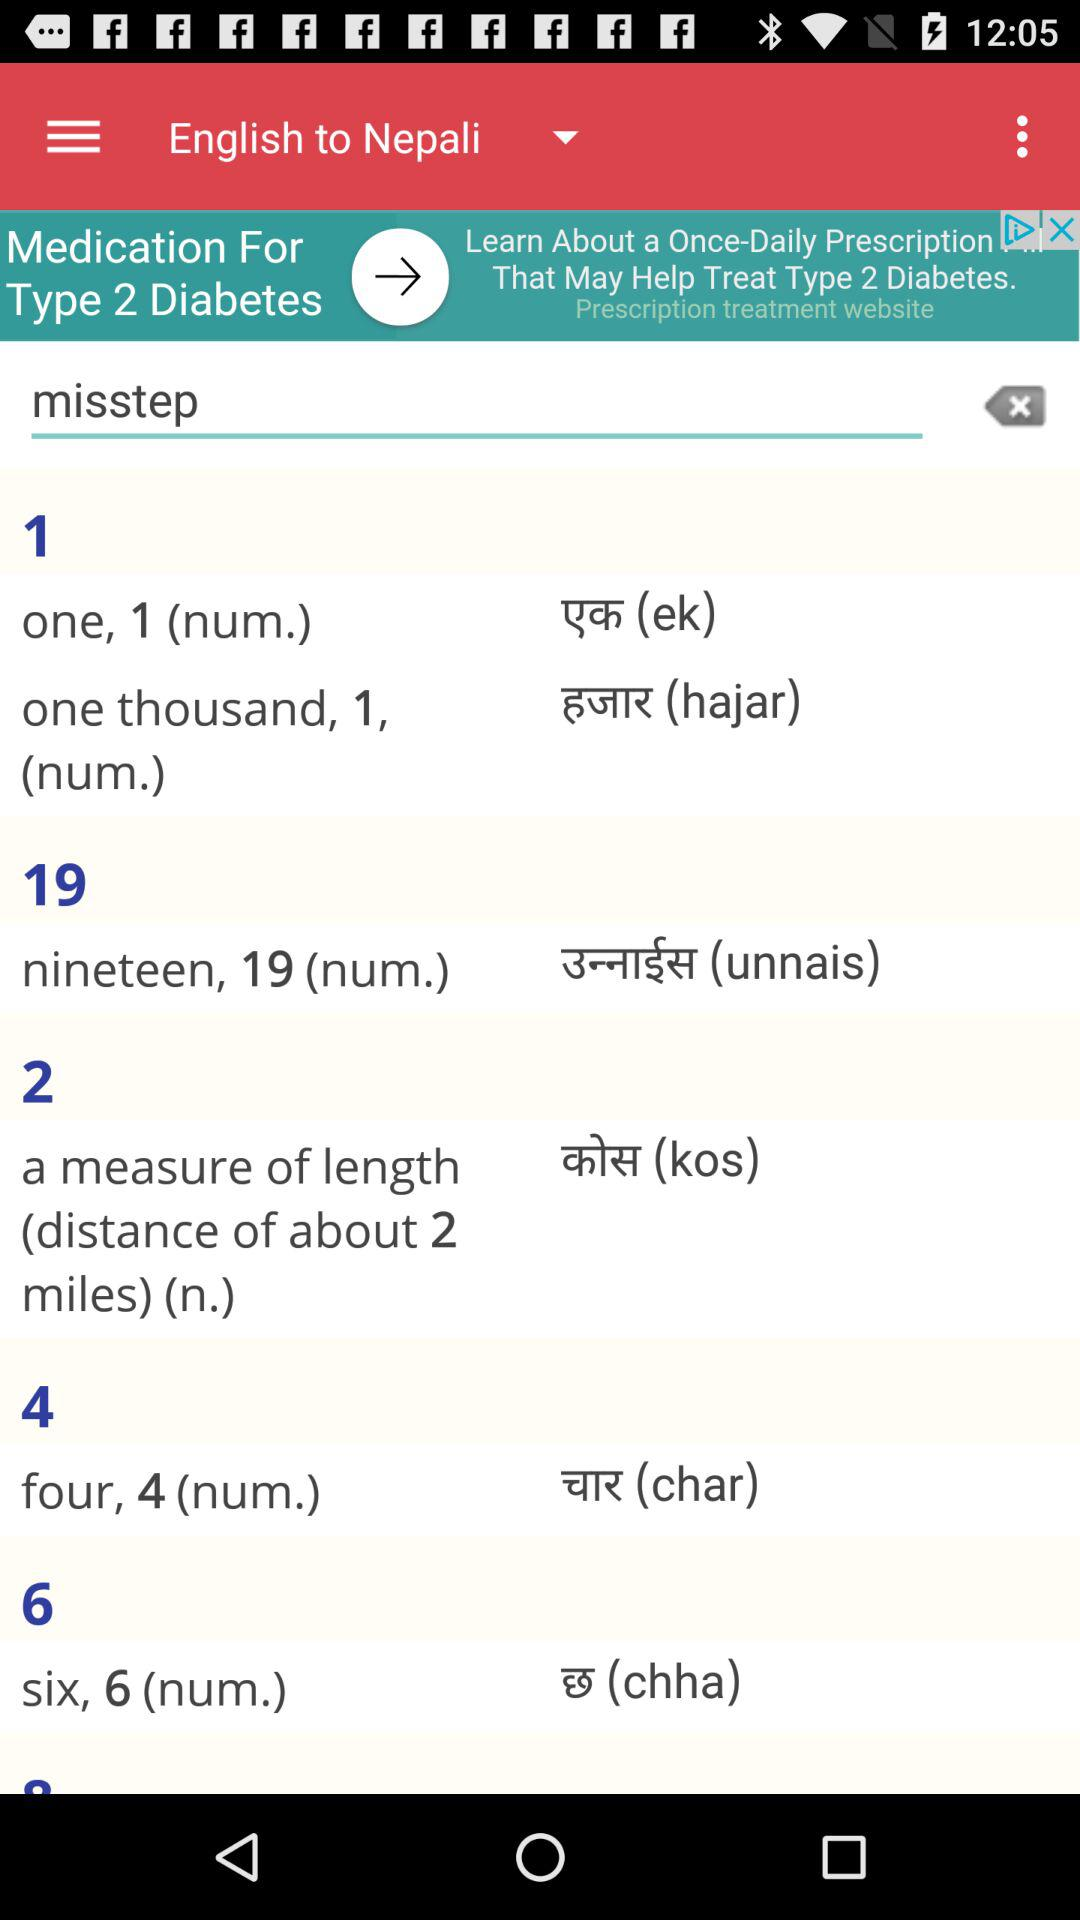What is the text entered in the text bar? The text entered in the text bar is "misstep". 